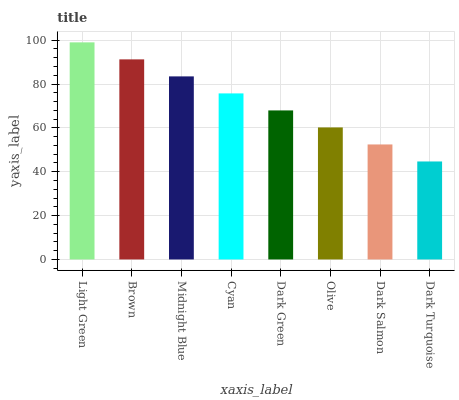Is Brown the minimum?
Answer yes or no. No. Is Brown the maximum?
Answer yes or no. No. Is Light Green greater than Brown?
Answer yes or no. Yes. Is Brown less than Light Green?
Answer yes or no. Yes. Is Brown greater than Light Green?
Answer yes or no. No. Is Light Green less than Brown?
Answer yes or no. No. Is Cyan the high median?
Answer yes or no. Yes. Is Dark Green the low median?
Answer yes or no. Yes. Is Brown the high median?
Answer yes or no. No. Is Cyan the low median?
Answer yes or no. No. 